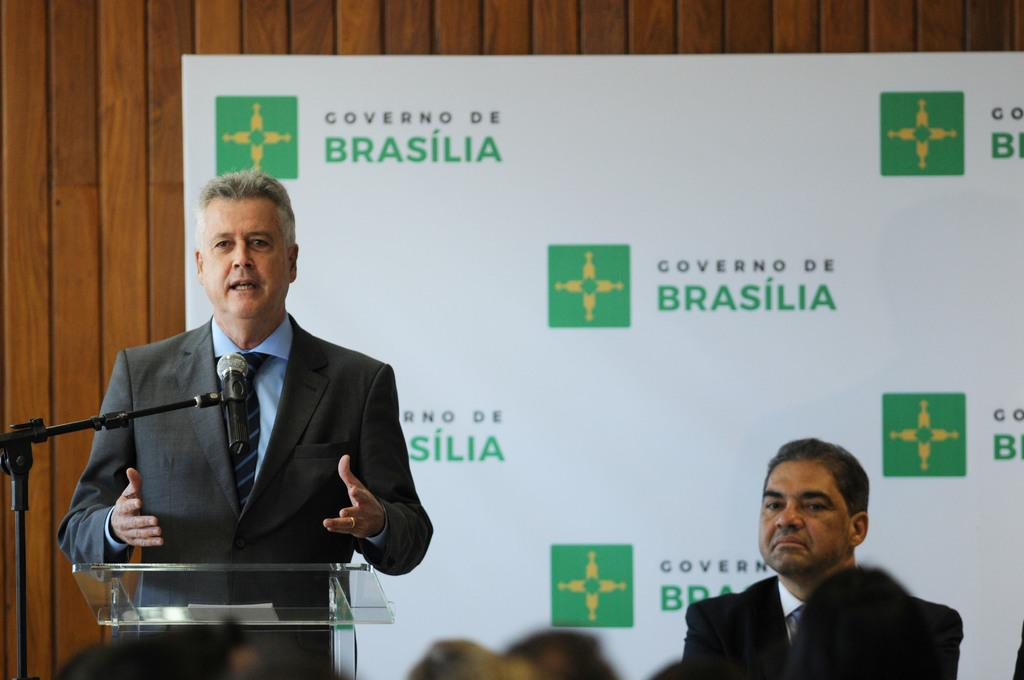What is the main subject of the image? There is a person in the image. What is in front of the person? There is a podium in front of the person. What is on the podium? There is a microphone on the podium. What can be seen in the background of the image? There is a wooden wall in the background, and there is a hoarding on the wooden wall. Are there any other people visible in the image? Yes, there are people visible in the image. What type of seed is being planted in the bucket in the image? There is no bucket or seed present in the image. How does the van contribute to the scene in the image? There is no van present in the image. 